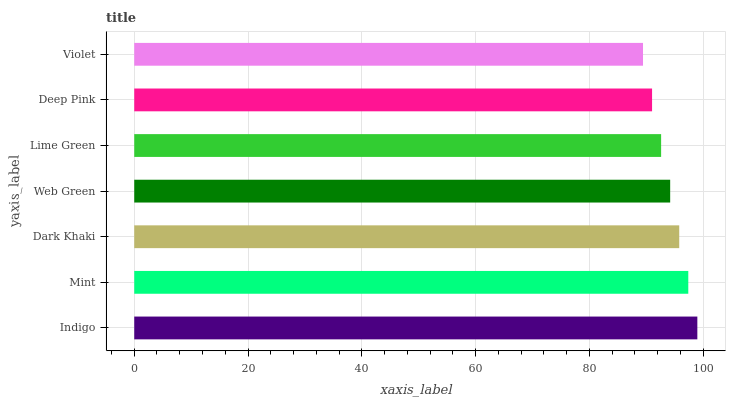Is Violet the minimum?
Answer yes or no. Yes. Is Indigo the maximum?
Answer yes or no. Yes. Is Mint the minimum?
Answer yes or no. No. Is Mint the maximum?
Answer yes or no. No. Is Indigo greater than Mint?
Answer yes or no. Yes. Is Mint less than Indigo?
Answer yes or no. Yes. Is Mint greater than Indigo?
Answer yes or no. No. Is Indigo less than Mint?
Answer yes or no. No. Is Web Green the high median?
Answer yes or no. Yes. Is Web Green the low median?
Answer yes or no. Yes. Is Violet the high median?
Answer yes or no. No. Is Lime Green the low median?
Answer yes or no. No. 